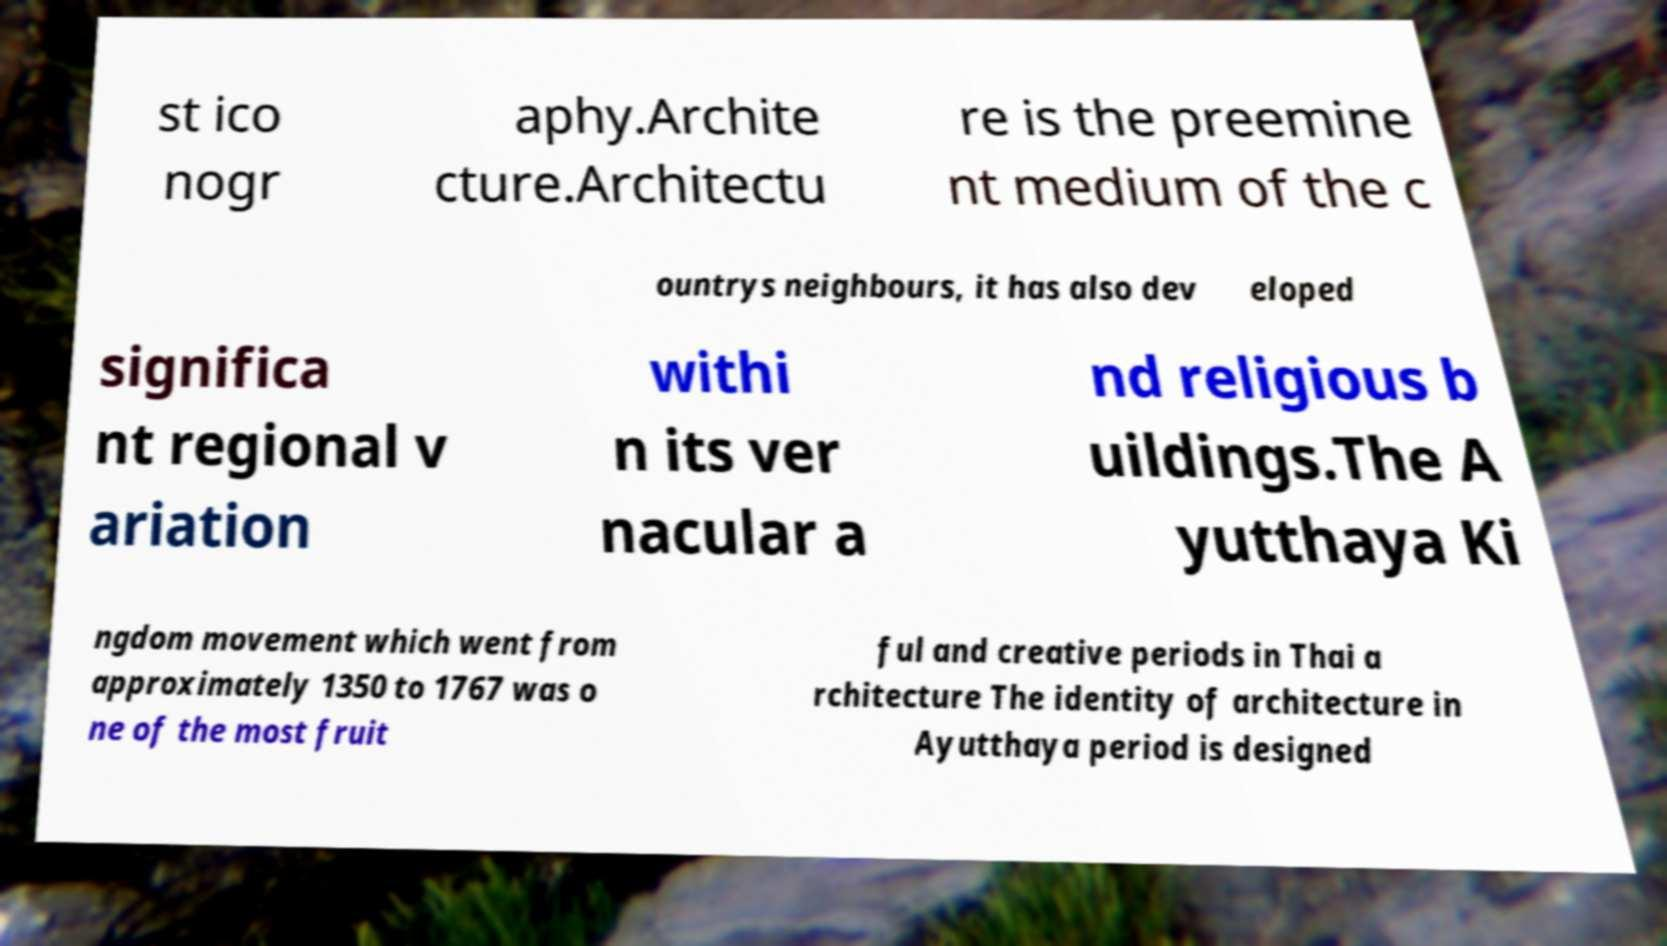Please identify and transcribe the text found in this image. st ico nogr aphy.Archite cture.Architectu re is the preemine nt medium of the c ountrys neighbours, it has also dev eloped significa nt regional v ariation withi n its ver nacular a nd religious b uildings.The A yutthaya Ki ngdom movement which went from approximately 1350 to 1767 was o ne of the most fruit ful and creative periods in Thai a rchitecture The identity of architecture in Ayutthaya period is designed 